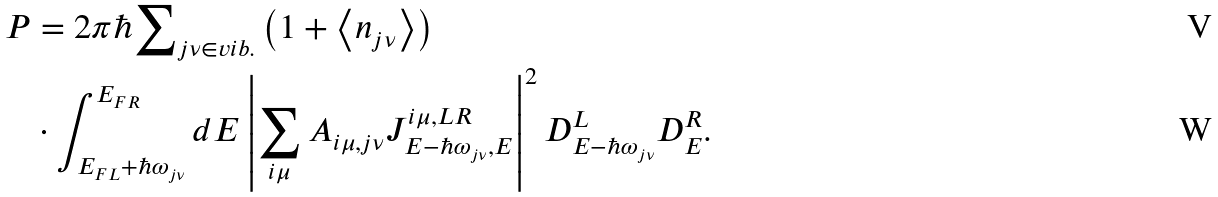Convert formula to latex. <formula><loc_0><loc_0><loc_500><loc_500>P & = 2 \pi \hbar { \sum } _ { j \nu \in v i b . } \left ( 1 + \left \langle n _ { j \nu } \right \rangle \right ) \\ & \cdot \int _ { E _ { F L } + \hbar { \omega } _ { j \nu } } ^ { E _ { F R } } d E \left | \sum _ { i \mu } A _ { i \mu , j \nu } J _ { E - \hbar { \omega } _ { j \nu } , E } ^ { i \mu , L R } \right | ^ { 2 } D _ { E - \hbar { \omega } _ { j \nu } } ^ { L } D _ { E } ^ { R } .</formula> 